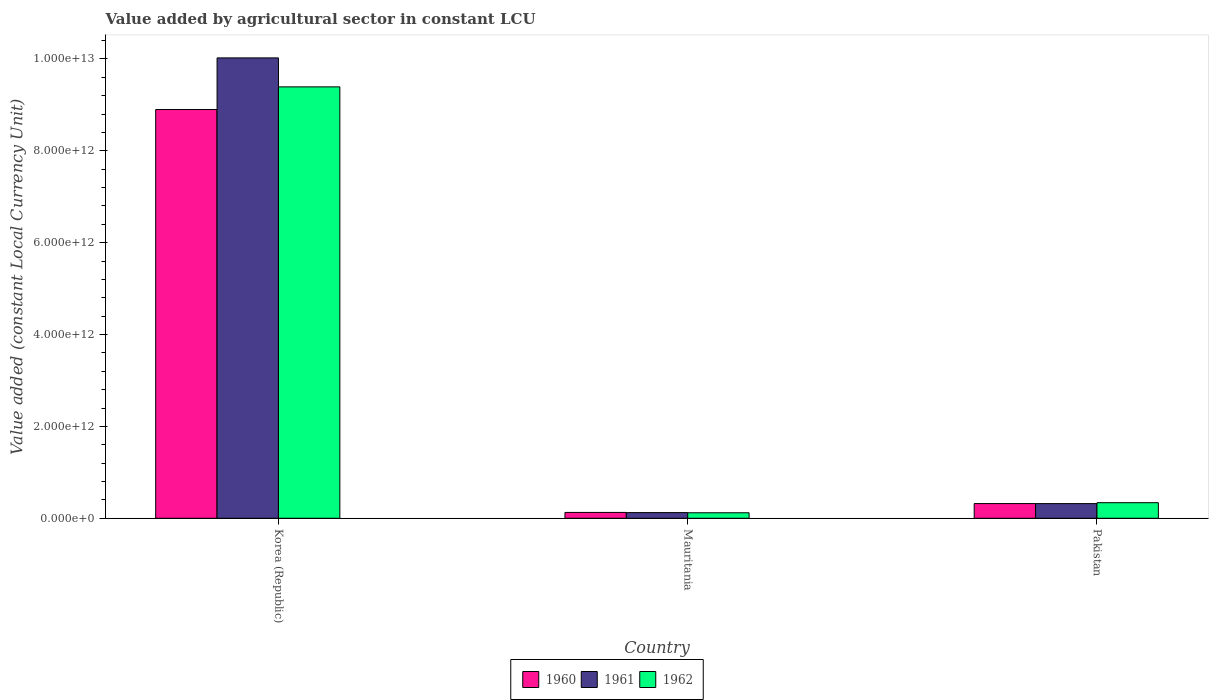What is the value added by agricultural sector in 1962 in Pakistan?
Make the answer very short. 3.39e+11. Across all countries, what is the maximum value added by agricultural sector in 1961?
Offer a very short reply. 1.00e+13. Across all countries, what is the minimum value added by agricultural sector in 1960?
Your response must be concise. 1.27e+11. In which country was the value added by agricultural sector in 1960 minimum?
Offer a terse response. Mauritania. What is the total value added by agricultural sector in 1961 in the graph?
Provide a succinct answer. 1.05e+13. What is the difference between the value added by agricultural sector in 1961 in Korea (Republic) and that in Mauritania?
Your response must be concise. 9.90e+12. What is the difference between the value added by agricultural sector in 1961 in Mauritania and the value added by agricultural sector in 1960 in Korea (Republic)?
Ensure brevity in your answer.  -8.77e+12. What is the average value added by agricultural sector in 1962 per country?
Keep it short and to the point. 3.28e+12. What is the difference between the value added by agricultural sector of/in 1961 and value added by agricultural sector of/in 1960 in Mauritania?
Your answer should be very brief. -4.01e+09. What is the ratio of the value added by agricultural sector in 1961 in Korea (Republic) to that in Pakistan?
Keep it short and to the point. 31.38. What is the difference between the highest and the second highest value added by agricultural sector in 1960?
Ensure brevity in your answer.  8.77e+12. What is the difference between the highest and the lowest value added by agricultural sector in 1961?
Your answer should be compact. 9.90e+12. In how many countries, is the value added by agricultural sector in 1960 greater than the average value added by agricultural sector in 1960 taken over all countries?
Your answer should be compact. 1. Is it the case that in every country, the sum of the value added by agricultural sector in 1961 and value added by agricultural sector in 1962 is greater than the value added by agricultural sector in 1960?
Your answer should be compact. Yes. How many bars are there?
Give a very brief answer. 9. Are all the bars in the graph horizontal?
Offer a terse response. No. What is the difference between two consecutive major ticks on the Y-axis?
Provide a short and direct response. 2.00e+12. Are the values on the major ticks of Y-axis written in scientific E-notation?
Your answer should be compact. Yes. What is the title of the graph?
Offer a terse response. Value added by agricultural sector in constant LCU. Does "1985" appear as one of the legend labels in the graph?
Ensure brevity in your answer.  No. What is the label or title of the X-axis?
Provide a short and direct response. Country. What is the label or title of the Y-axis?
Ensure brevity in your answer.  Value added (constant Local Currency Unit). What is the Value added (constant Local Currency Unit) of 1960 in Korea (Republic)?
Your answer should be very brief. 8.90e+12. What is the Value added (constant Local Currency Unit) of 1961 in Korea (Republic)?
Offer a very short reply. 1.00e+13. What is the Value added (constant Local Currency Unit) of 1962 in Korea (Republic)?
Provide a succinct answer. 9.39e+12. What is the Value added (constant Local Currency Unit) of 1960 in Mauritania?
Your answer should be compact. 1.27e+11. What is the Value added (constant Local Currency Unit) of 1961 in Mauritania?
Keep it short and to the point. 1.23e+11. What is the Value added (constant Local Currency Unit) of 1962 in Mauritania?
Give a very brief answer. 1.20e+11. What is the Value added (constant Local Currency Unit) in 1960 in Pakistan?
Keep it short and to the point. 3.20e+11. What is the Value added (constant Local Currency Unit) in 1961 in Pakistan?
Offer a very short reply. 3.19e+11. What is the Value added (constant Local Currency Unit) in 1962 in Pakistan?
Keep it short and to the point. 3.39e+11. Across all countries, what is the maximum Value added (constant Local Currency Unit) of 1960?
Make the answer very short. 8.90e+12. Across all countries, what is the maximum Value added (constant Local Currency Unit) of 1961?
Make the answer very short. 1.00e+13. Across all countries, what is the maximum Value added (constant Local Currency Unit) in 1962?
Keep it short and to the point. 9.39e+12. Across all countries, what is the minimum Value added (constant Local Currency Unit) in 1960?
Your response must be concise. 1.27e+11. Across all countries, what is the minimum Value added (constant Local Currency Unit) of 1961?
Make the answer very short. 1.23e+11. Across all countries, what is the minimum Value added (constant Local Currency Unit) of 1962?
Offer a very short reply. 1.20e+11. What is the total Value added (constant Local Currency Unit) of 1960 in the graph?
Your answer should be very brief. 9.35e+12. What is the total Value added (constant Local Currency Unit) of 1961 in the graph?
Your response must be concise. 1.05e+13. What is the total Value added (constant Local Currency Unit) in 1962 in the graph?
Offer a very short reply. 9.85e+12. What is the difference between the Value added (constant Local Currency Unit) in 1960 in Korea (Republic) and that in Mauritania?
Your response must be concise. 8.77e+12. What is the difference between the Value added (constant Local Currency Unit) of 1961 in Korea (Republic) and that in Mauritania?
Your answer should be very brief. 9.90e+12. What is the difference between the Value added (constant Local Currency Unit) in 1962 in Korea (Republic) and that in Mauritania?
Keep it short and to the point. 9.27e+12. What is the difference between the Value added (constant Local Currency Unit) in 1960 in Korea (Republic) and that in Pakistan?
Ensure brevity in your answer.  8.58e+12. What is the difference between the Value added (constant Local Currency Unit) in 1961 in Korea (Republic) and that in Pakistan?
Your answer should be compact. 9.70e+12. What is the difference between the Value added (constant Local Currency Unit) in 1962 in Korea (Republic) and that in Pakistan?
Keep it short and to the point. 9.05e+12. What is the difference between the Value added (constant Local Currency Unit) of 1960 in Mauritania and that in Pakistan?
Make the answer very short. -1.93e+11. What is the difference between the Value added (constant Local Currency Unit) in 1961 in Mauritania and that in Pakistan?
Offer a very short reply. -1.96e+11. What is the difference between the Value added (constant Local Currency Unit) in 1962 in Mauritania and that in Pakistan?
Your answer should be compact. -2.20e+11. What is the difference between the Value added (constant Local Currency Unit) in 1960 in Korea (Republic) and the Value added (constant Local Currency Unit) in 1961 in Mauritania?
Keep it short and to the point. 8.77e+12. What is the difference between the Value added (constant Local Currency Unit) of 1960 in Korea (Republic) and the Value added (constant Local Currency Unit) of 1962 in Mauritania?
Keep it short and to the point. 8.78e+12. What is the difference between the Value added (constant Local Currency Unit) of 1961 in Korea (Republic) and the Value added (constant Local Currency Unit) of 1962 in Mauritania?
Your answer should be very brief. 9.90e+12. What is the difference between the Value added (constant Local Currency Unit) in 1960 in Korea (Republic) and the Value added (constant Local Currency Unit) in 1961 in Pakistan?
Your answer should be very brief. 8.58e+12. What is the difference between the Value added (constant Local Currency Unit) in 1960 in Korea (Republic) and the Value added (constant Local Currency Unit) in 1962 in Pakistan?
Keep it short and to the point. 8.56e+12. What is the difference between the Value added (constant Local Currency Unit) of 1961 in Korea (Republic) and the Value added (constant Local Currency Unit) of 1962 in Pakistan?
Ensure brevity in your answer.  9.68e+12. What is the difference between the Value added (constant Local Currency Unit) of 1960 in Mauritania and the Value added (constant Local Currency Unit) of 1961 in Pakistan?
Give a very brief answer. -1.92e+11. What is the difference between the Value added (constant Local Currency Unit) in 1960 in Mauritania and the Value added (constant Local Currency Unit) in 1962 in Pakistan?
Provide a succinct answer. -2.12e+11. What is the difference between the Value added (constant Local Currency Unit) of 1961 in Mauritania and the Value added (constant Local Currency Unit) of 1962 in Pakistan?
Your response must be concise. -2.16e+11. What is the average Value added (constant Local Currency Unit) of 1960 per country?
Keep it short and to the point. 3.12e+12. What is the average Value added (constant Local Currency Unit) in 1961 per country?
Keep it short and to the point. 3.49e+12. What is the average Value added (constant Local Currency Unit) in 1962 per country?
Your response must be concise. 3.28e+12. What is the difference between the Value added (constant Local Currency Unit) of 1960 and Value added (constant Local Currency Unit) of 1961 in Korea (Republic)?
Your answer should be compact. -1.12e+12. What is the difference between the Value added (constant Local Currency Unit) of 1960 and Value added (constant Local Currency Unit) of 1962 in Korea (Republic)?
Ensure brevity in your answer.  -4.93e+11. What is the difference between the Value added (constant Local Currency Unit) of 1961 and Value added (constant Local Currency Unit) of 1962 in Korea (Republic)?
Your answer should be compact. 6.31e+11. What is the difference between the Value added (constant Local Currency Unit) in 1960 and Value added (constant Local Currency Unit) in 1961 in Mauritania?
Give a very brief answer. 4.01e+09. What is the difference between the Value added (constant Local Currency Unit) in 1960 and Value added (constant Local Currency Unit) in 1962 in Mauritania?
Give a very brief answer. 7.67e+09. What is the difference between the Value added (constant Local Currency Unit) of 1961 and Value added (constant Local Currency Unit) of 1962 in Mauritania?
Keep it short and to the point. 3.65e+09. What is the difference between the Value added (constant Local Currency Unit) of 1960 and Value added (constant Local Currency Unit) of 1961 in Pakistan?
Offer a terse response. 6.46e+08. What is the difference between the Value added (constant Local Currency Unit) in 1960 and Value added (constant Local Currency Unit) in 1962 in Pakistan?
Your response must be concise. -1.91e+1. What is the difference between the Value added (constant Local Currency Unit) in 1961 and Value added (constant Local Currency Unit) in 1962 in Pakistan?
Provide a succinct answer. -1.97e+1. What is the ratio of the Value added (constant Local Currency Unit) of 1960 in Korea (Republic) to that in Mauritania?
Your answer should be very brief. 69.9. What is the ratio of the Value added (constant Local Currency Unit) in 1961 in Korea (Republic) to that in Mauritania?
Your answer should be compact. 81.29. What is the ratio of the Value added (constant Local Currency Unit) in 1962 in Korea (Republic) to that in Mauritania?
Your response must be concise. 78.51. What is the ratio of the Value added (constant Local Currency Unit) of 1960 in Korea (Republic) to that in Pakistan?
Your answer should be compact. 27.8. What is the ratio of the Value added (constant Local Currency Unit) of 1961 in Korea (Republic) to that in Pakistan?
Your answer should be very brief. 31.38. What is the ratio of the Value added (constant Local Currency Unit) in 1962 in Korea (Republic) to that in Pakistan?
Offer a terse response. 27.69. What is the ratio of the Value added (constant Local Currency Unit) in 1960 in Mauritania to that in Pakistan?
Offer a very short reply. 0.4. What is the ratio of the Value added (constant Local Currency Unit) in 1961 in Mauritania to that in Pakistan?
Your answer should be very brief. 0.39. What is the ratio of the Value added (constant Local Currency Unit) of 1962 in Mauritania to that in Pakistan?
Make the answer very short. 0.35. What is the difference between the highest and the second highest Value added (constant Local Currency Unit) in 1960?
Offer a terse response. 8.58e+12. What is the difference between the highest and the second highest Value added (constant Local Currency Unit) in 1961?
Offer a terse response. 9.70e+12. What is the difference between the highest and the second highest Value added (constant Local Currency Unit) of 1962?
Your answer should be compact. 9.05e+12. What is the difference between the highest and the lowest Value added (constant Local Currency Unit) of 1960?
Make the answer very short. 8.77e+12. What is the difference between the highest and the lowest Value added (constant Local Currency Unit) in 1961?
Offer a very short reply. 9.90e+12. What is the difference between the highest and the lowest Value added (constant Local Currency Unit) of 1962?
Provide a short and direct response. 9.27e+12. 